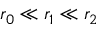Convert formula to latex. <formula><loc_0><loc_0><loc_500><loc_500>r _ { 0 } \ll r _ { 1 } \ll r _ { 2 }</formula> 